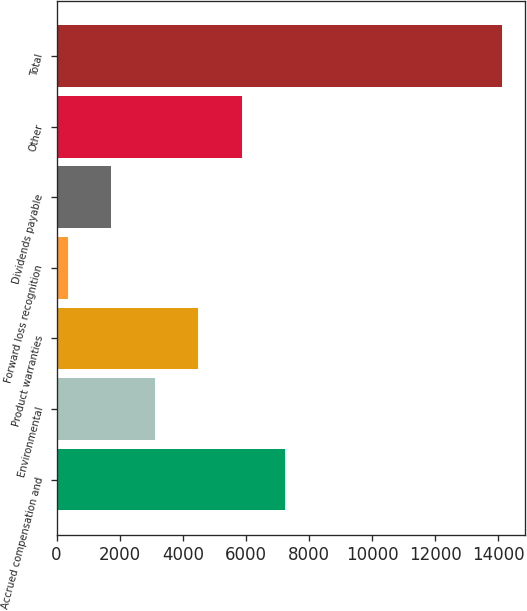<chart> <loc_0><loc_0><loc_500><loc_500><bar_chart><fcel>Accrued compensation and<fcel>Environmental<fcel>Product warranties<fcel>Forward loss recognition<fcel>Dividends payable<fcel>Other<fcel>Total<nl><fcel>7245.5<fcel>3114.2<fcel>4491.3<fcel>360<fcel>1737.1<fcel>5868.4<fcel>14131<nl></chart> 